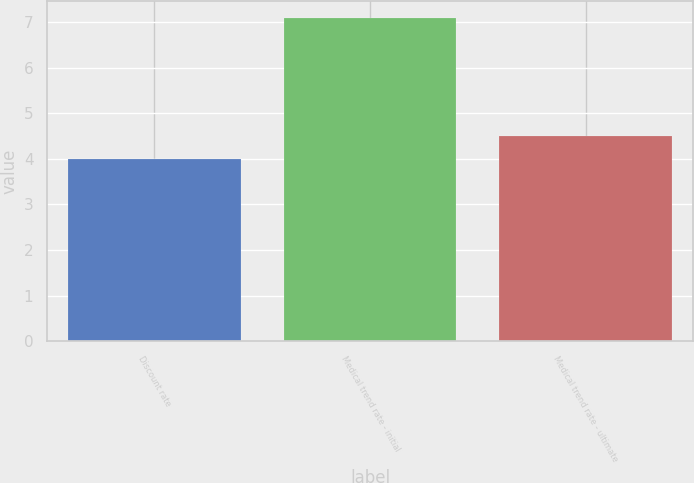Convert chart. <chart><loc_0><loc_0><loc_500><loc_500><bar_chart><fcel>Discount rate<fcel>Medical trend rate - initial<fcel>Medical trend rate - ultimate<nl><fcel>4<fcel>7.1<fcel>4.5<nl></chart> 